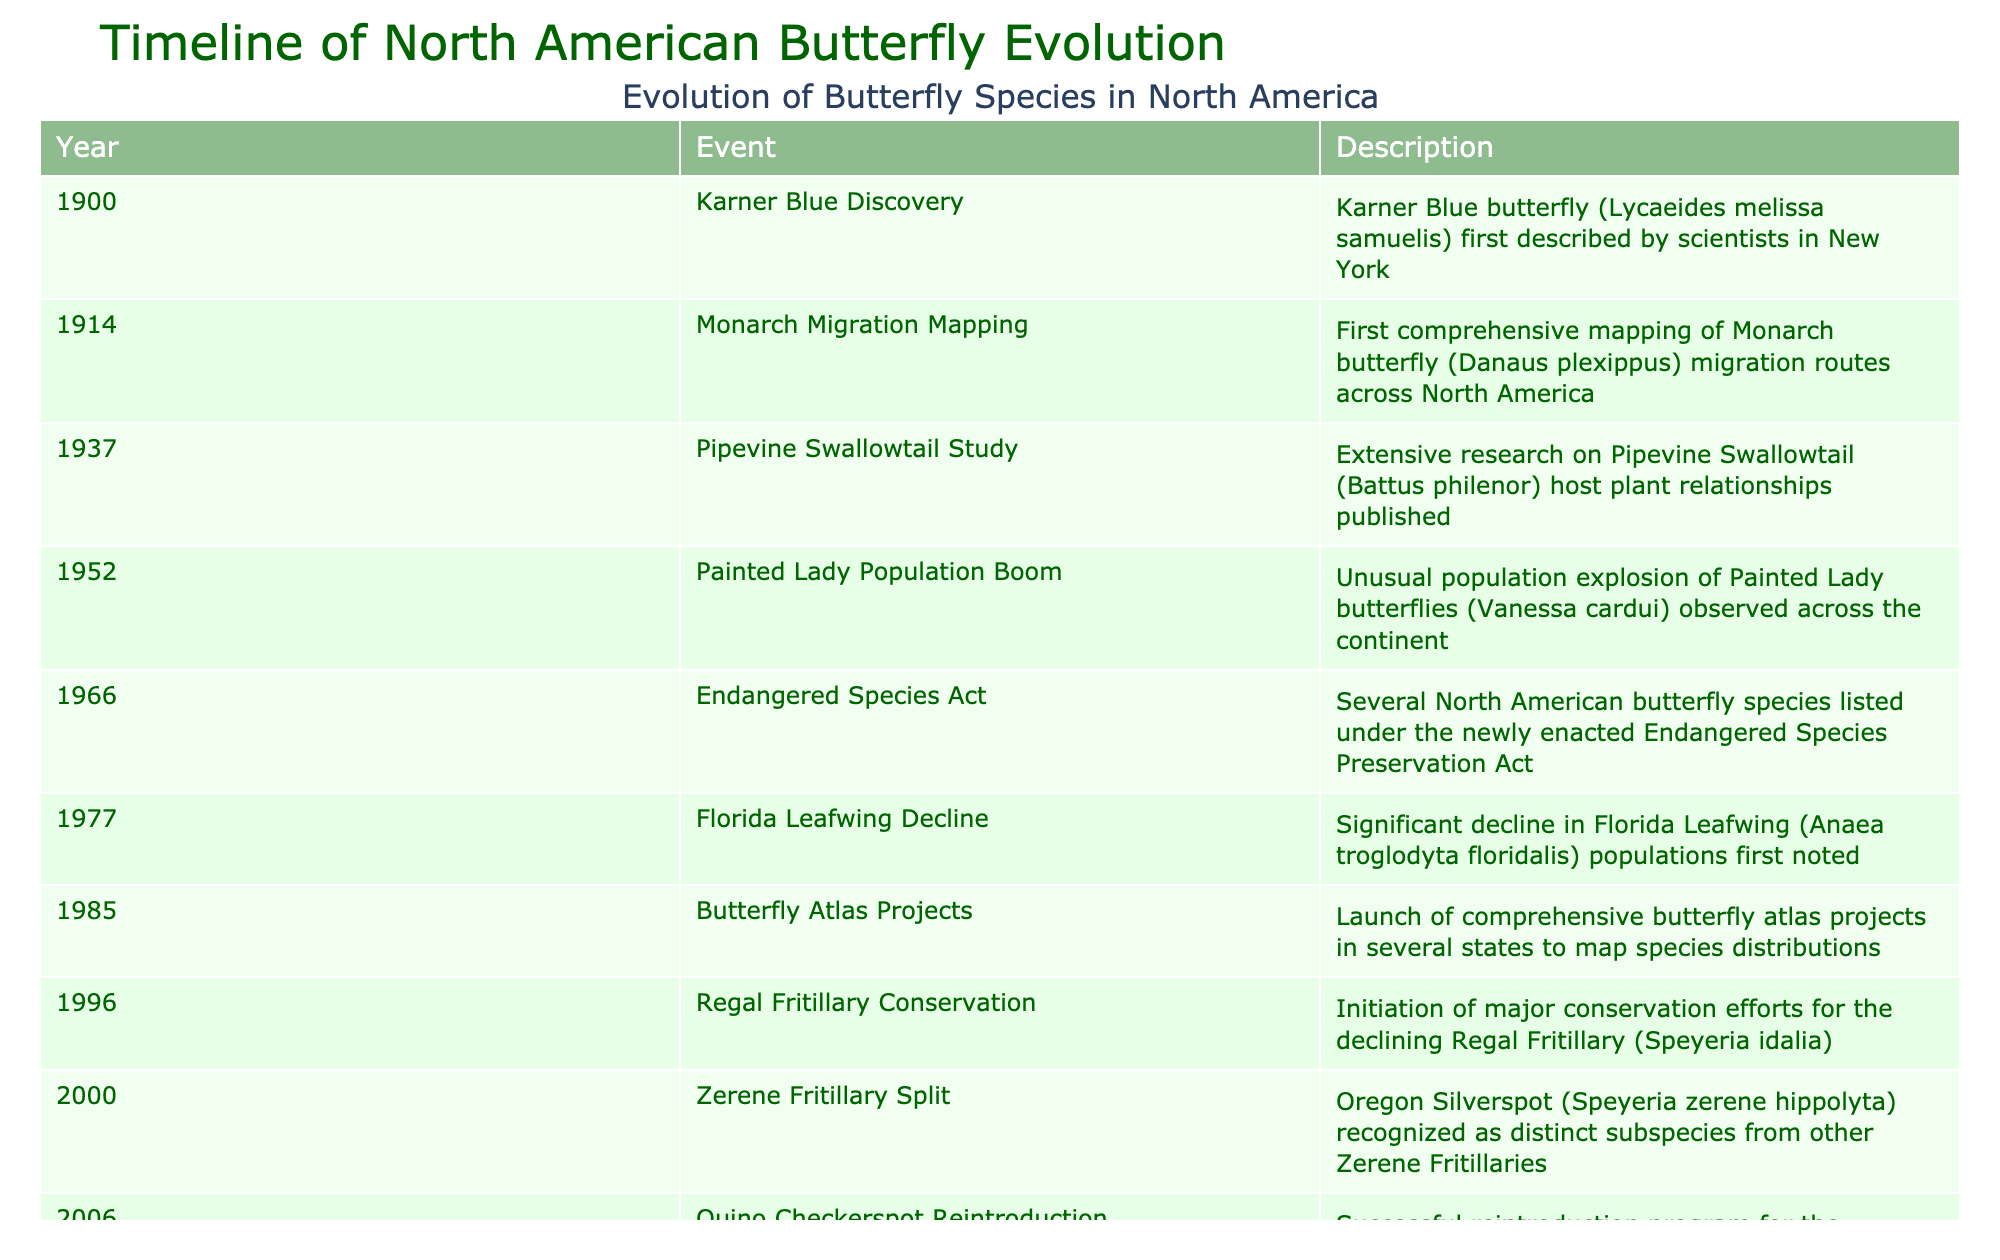What was the first butterfly species discovered in North America? The table lists events with corresponding years. The earliest event is from 1900, describing the Karner Blue butterfly as the first one identified by scientists in New York.
Answer: Karner Blue Which year did the population boom of Painted Lady butterflies occur? The table shows an event in 1952 highlighting a significant population explosion of Painted Lady butterflies.
Answer: 1952 Did the Endangered Species Act lead to any butterfly species being listed as endangered? According to the 1966 entry in the table, several North American butterfly species were indeed listed under the Endangered Species Preservation Act that year.
Answer: Yes How many events occurred that relate to conservation efforts? Looking through the table, the events related to conservation efforts are the Regal Fritillary in 1996, Quino Checkerspot in 2006, and the mapping projects in 1985. That makes a total of three conservation-related events.
Answer: 3 What is the time span from the discovery of the Karner Blue to the Rocky Mountain butterfly shifts? The first event is in 1900 and the last event in the table is in 2021. To find the time span, subtract 1900 from 2021, which gives us 121 years.
Answer: 121 years What is the significance of the year 1985 in the context of butterfly species? The table notes that in 1985, comprehensive butterfly atlas projects were launched across several states to map species distributions, marking a significant movement towards understanding butterfly populations.
Answer: Launch of atlas projects Which butterfly had a notable shift in altitudinal distribution? The 2021 entry indicates that a study revealed significant shifts in the altitudinal distribution of Rocky Mountain butterfly species due to climate change.
Answer: Rocky Mountain butterflies Was there a butterfly species listed for the first time in the 21st century? The table shows that in the year 2000, the Oregon Silverspot was recognized as a distinct subspecies, indicating that it was listed for the first time in the 21st century.
Answer: Yes How many years after the decline of the Florida Leafwing was the reintroduction of the Quino Checkerspot? The Florida Leafwing decline was noted in 1977, and the Quino Checkerspot reintroduction happened in 2006. The difference between these years is 2006 - 1977, which is 29 years.
Answer: 29 years 